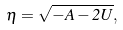<formula> <loc_0><loc_0><loc_500><loc_500>\eta = \sqrt { - A - 2 U } ,</formula> 